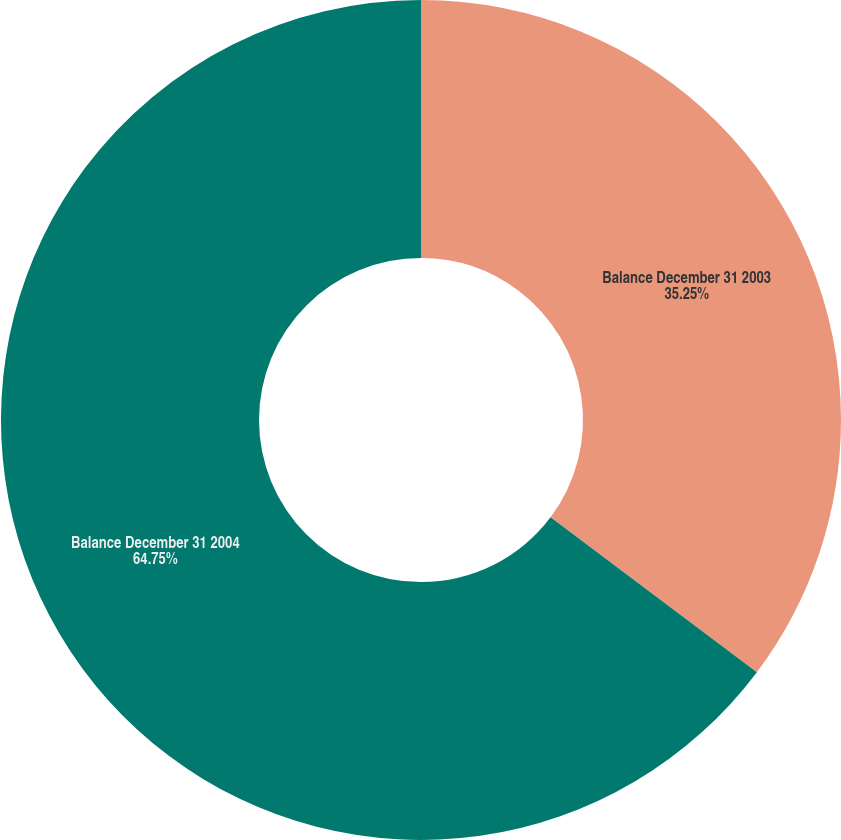<chart> <loc_0><loc_0><loc_500><loc_500><pie_chart><fcel>Balance December 31 2003<fcel>Balance December 31 2004<nl><fcel>35.25%<fcel>64.75%<nl></chart> 